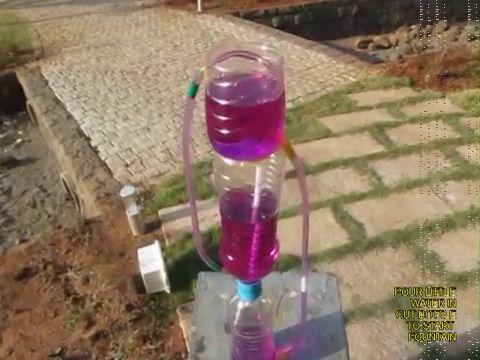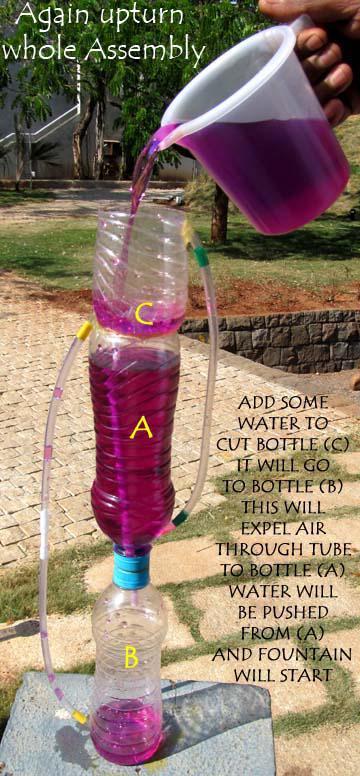The first image is the image on the left, the second image is the image on the right. Assess this claim about the two images: "One of the images features a person demonstrating the fountain.". Correct or not? Answer yes or no. Yes. The first image is the image on the left, the second image is the image on the right. Evaluate the accuracy of this statement regarding the images: "Each image shows a set-up with purple liquid flowing from the top to the bottom, with blue bottle caps visible in each picture.". Is it true? Answer yes or no. Yes. 